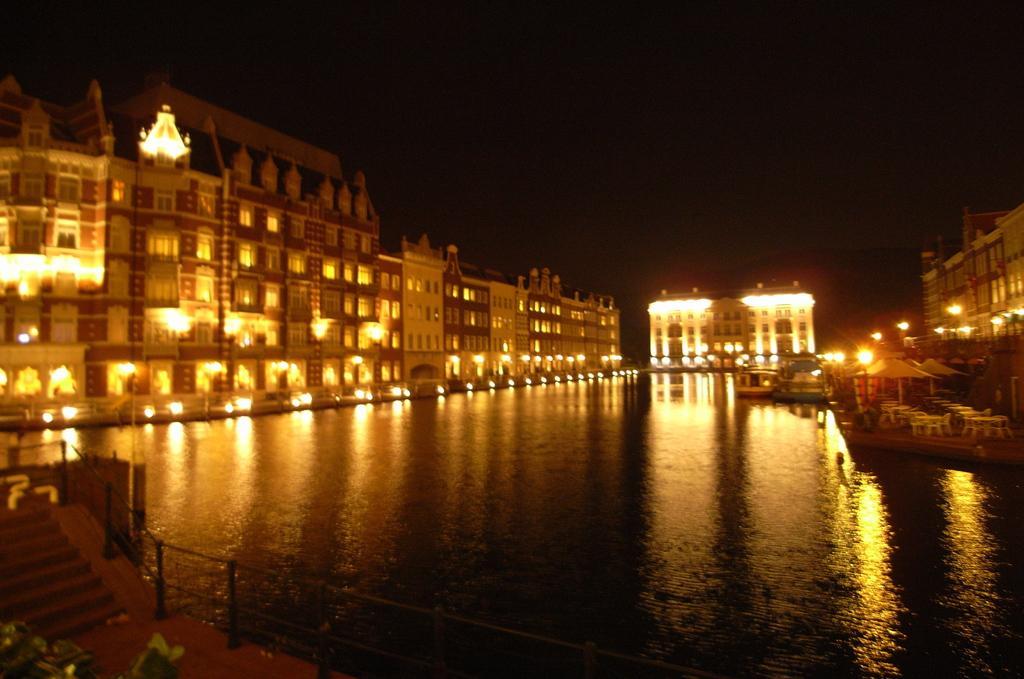Could you give a brief overview of what you see in this image? In this image I see number of buildings and I see the lights and I see the water over here and I see a boat over here and I see the chairs and tables over here and I see the steps over here and it is in the background. 